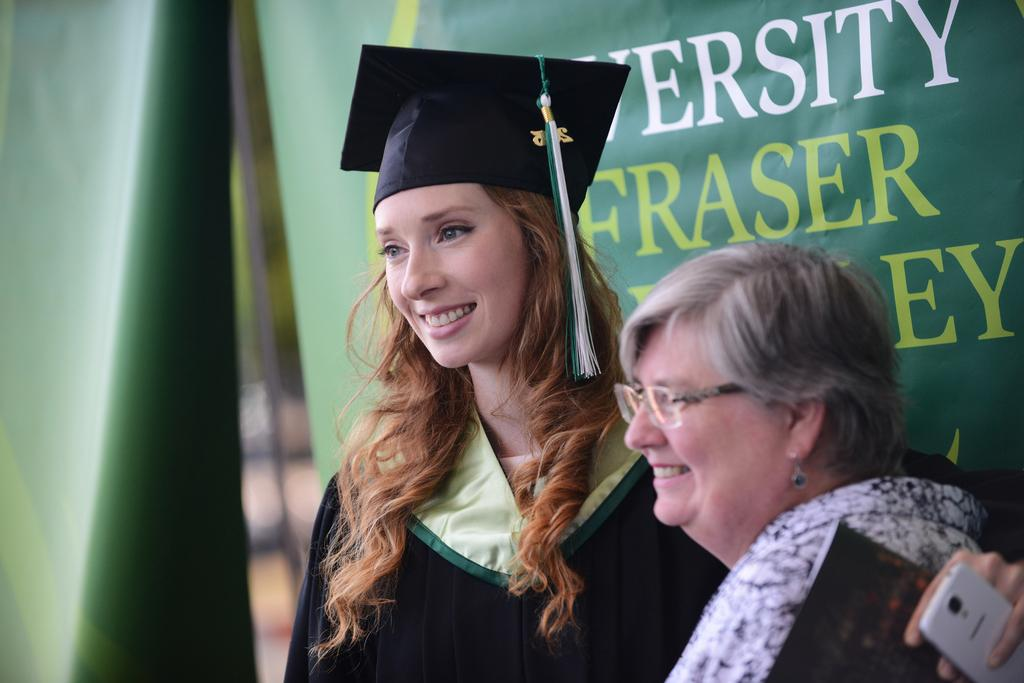How many people are in the image? There are two women in the image. What are the women doing in the image? The women are standing and smiling. What can be seen in the background of the image? There is a green colored banner in the background. What is written on the banner? There are letters written on the banner. What type of baseball equipment can be seen in the image? There is no baseball equipment present in the image. How many family members are visible in the image? The image only features two women, so it cannot be determined if they are part of a family or not. 